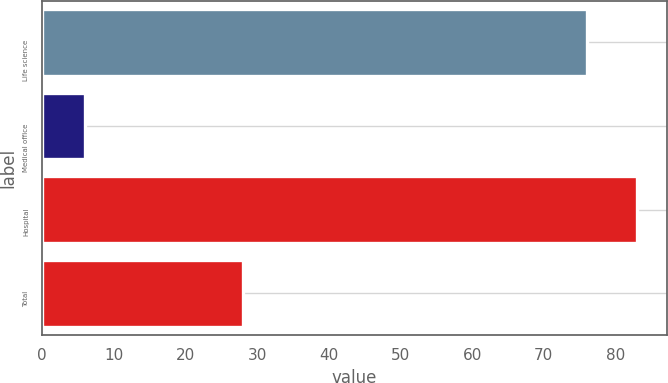<chart> <loc_0><loc_0><loc_500><loc_500><bar_chart><fcel>Life science<fcel>Medical office<fcel>Hospital<fcel>Total<nl><fcel>76<fcel>6<fcel>83<fcel>28<nl></chart> 